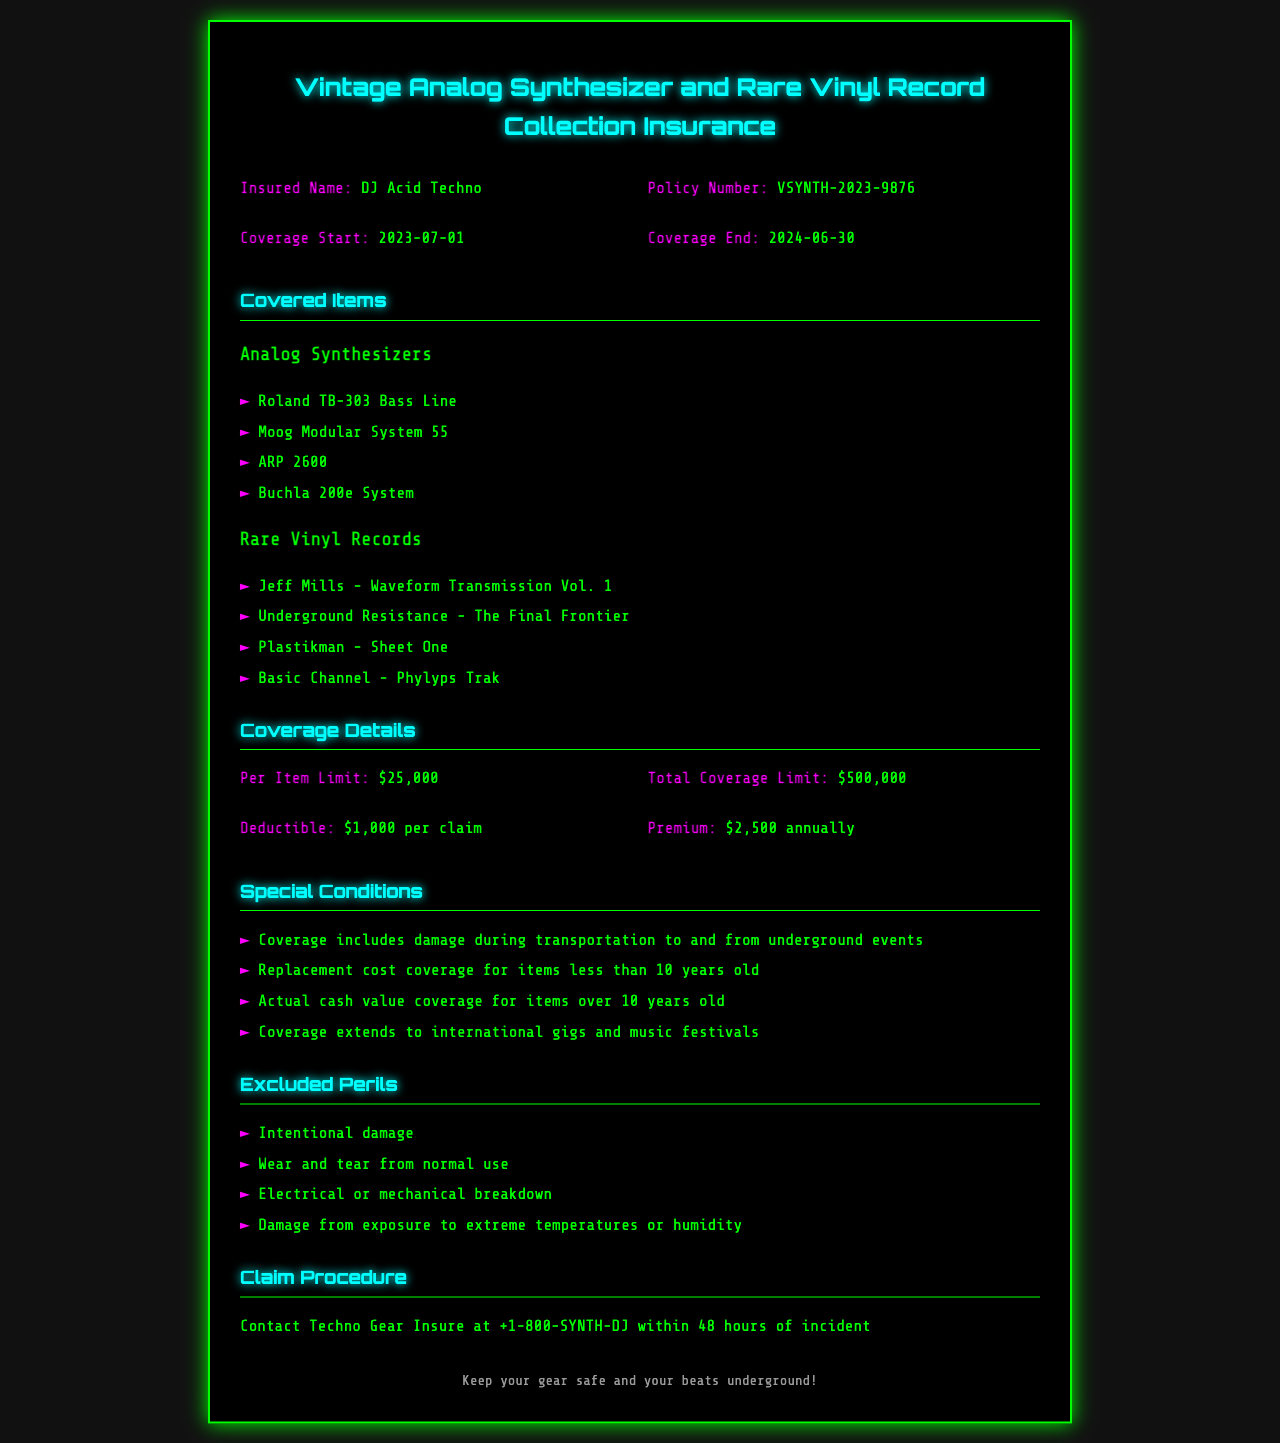What is the insured name? The insured name is listed in the document under the 'Insured Name' section as "DJ Acid Techno."
Answer: DJ Acid Techno What is the policy number? The policy number is found in the 'Policy Number' section of the document which states "VSYNTH-2023-9876."
Answer: VSYNTH-2023-9876 What is the coverage end date? The coverage end date is specified in the document as "2024-06-30."
Answer: 2024-06-30 What is the total coverage limit? The total coverage limit is clearly outlined in the 'Coverage Details' section as "$500,000."
Answer: $500,000 What does the deductible amount? The deductible amount is stated in the 'Coverage Details' section as "$1,000 per claim."
Answer: $1,000 per claim What is covered in special conditions related to events? The special conditions include "damage during transportation to and from underground events."
Answer: damage during transportation to and from underground events What type of coverage applies for items over 10 years old? The document specifies "Actual cash value coverage for items over 10 years old."
Answer: Actual cash value coverage What are excluded perils related to wear and tear? The document explicitly states "Wear and tear from normal use" is an excluded peril.
Answer: Wear and tear from normal use What should be done within 48 hours of an incident? The document instructs to "Contact Techno Gear Insure at +1-800-SYNTH-DJ within 48 hours of incident."
Answer: Contact Techno Gear Insure at +1-800-SYNTH-DJ What is the annual premium for the policy? The annual premium is listed in the 'Coverage Details' section as "$2,500 annually."
Answer: $2,500 annually 